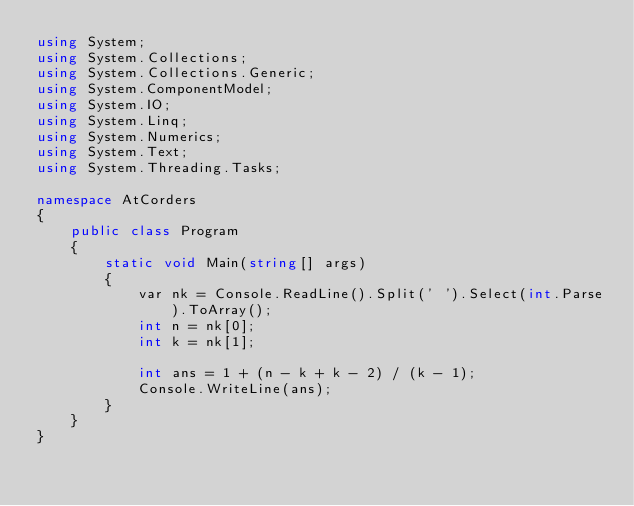Convert code to text. <code><loc_0><loc_0><loc_500><loc_500><_C#_>using System;
using System.Collections;
using System.Collections.Generic;
using System.ComponentModel;
using System.IO;
using System.Linq;
using System.Numerics;
using System.Text;
using System.Threading.Tasks;

namespace AtCorders
{
	public class Program
	{
		static void Main(string[] args)
		{
			var nk = Console.ReadLine().Split(' ').Select(int.Parse).ToArray();
			int n = nk[0];
			int k = nk[1];
			
			int ans = 1 + (n - k + k - 2) / (k - 1);
			Console.WriteLine(ans);
		}
	}
}</code> 